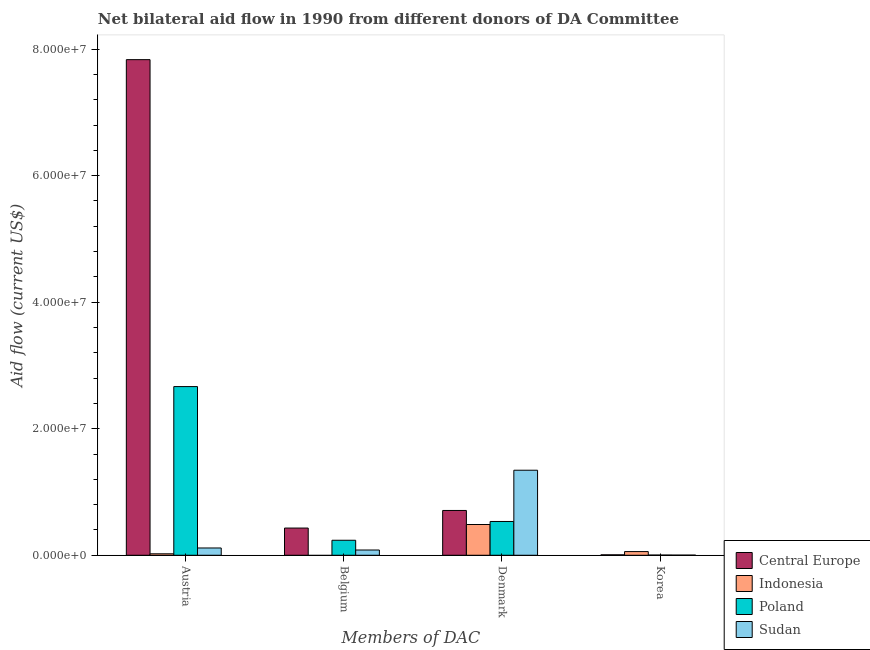How many different coloured bars are there?
Keep it short and to the point. 4. How many bars are there on the 3rd tick from the left?
Your answer should be compact. 4. What is the label of the 2nd group of bars from the left?
Your answer should be very brief. Belgium. What is the amount of aid given by austria in Central Europe?
Your answer should be compact. 7.83e+07. Across all countries, what is the maximum amount of aid given by belgium?
Offer a very short reply. 4.30e+06. Across all countries, what is the minimum amount of aid given by korea?
Your answer should be compact. 2.00e+04. In which country was the amount of aid given by belgium maximum?
Offer a very short reply. Central Europe. What is the total amount of aid given by denmark in the graph?
Keep it short and to the point. 3.07e+07. What is the difference between the amount of aid given by denmark in Poland and that in Sudan?
Your answer should be compact. -8.10e+06. What is the difference between the amount of aid given by belgium in Central Europe and the amount of aid given by austria in Poland?
Give a very brief answer. -2.24e+07. What is the average amount of aid given by belgium per country?
Provide a short and direct response. 1.88e+06. What is the difference between the amount of aid given by belgium and amount of aid given by austria in Sudan?
Provide a short and direct response. -3.20e+05. What is the ratio of the amount of aid given by austria in Indonesia to that in Central Europe?
Keep it short and to the point. 0. Is the amount of aid given by belgium in Sudan less than that in Central Europe?
Your answer should be very brief. Yes. Is the difference between the amount of aid given by korea in Central Europe and Indonesia greater than the difference between the amount of aid given by denmark in Central Europe and Indonesia?
Your response must be concise. No. What is the difference between the highest and the second highest amount of aid given by denmark?
Offer a very short reply. 6.36e+06. What is the difference between the highest and the lowest amount of aid given by belgium?
Provide a succinct answer. 4.30e+06. How many bars are there?
Your response must be concise. 15. How many countries are there in the graph?
Provide a short and direct response. 4. How are the legend labels stacked?
Provide a short and direct response. Vertical. What is the title of the graph?
Your answer should be compact. Net bilateral aid flow in 1990 from different donors of DA Committee. What is the label or title of the X-axis?
Offer a terse response. Members of DAC. What is the Aid flow (current US$) of Central Europe in Austria?
Make the answer very short. 7.83e+07. What is the Aid flow (current US$) in Poland in Austria?
Your answer should be compact. 2.67e+07. What is the Aid flow (current US$) in Sudan in Austria?
Your answer should be compact. 1.15e+06. What is the Aid flow (current US$) in Central Europe in Belgium?
Offer a terse response. 4.30e+06. What is the Aid flow (current US$) of Indonesia in Belgium?
Give a very brief answer. 0. What is the Aid flow (current US$) in Poland in Belgium?
Make the answer very short. 2.37e+06. What is the Aid flow (current US$) in Sudan in Belgium?
Your answer should be very brief. 8.30e+05. What is the Aid flow (current US$) in Central Europe in Denmark?
Provide a succinct answer. 7.08e+06. What is the Aid flow (current US$) of Indonesia in Denmark?
Offer a terse response. 4.86e+06. What is the Aid flow (current US$) in Poland in Denmark?
Offer a terse response. 5.34e+06. What is the Aid flow (current US$) in Sudan in Denmark?
Provide a short and direct response. 1.34e+07. What is the Aid flow (current US$) in Indonesia in Korea?
Offer a very short reply. 5.80e+05. Across all Members of DAC, what is the maximum Aid flow (current US$) in Central Europe?
Offer a very short reply. 7.83e+07. Across all Members of DAC, what is the maximum Aid flow (current US$) of Indonesia?
Your response must be concise. 4.86e+06. Across all Members of DAC, what is the maximum Aid flow (current US$) in Poland?
Your answer should be very brief. 2.67e+07. Across all Members of DAC, what is the maximum Aid flow (current US$) in Sudan?
Your answer should be compact. 1.34e+07. Across all Members of DAC, what is the minimum Aid flow (current US$) in Central Europe?
Ensure brevity in your answer.  7.00e+04. Across all Members of DAC, what is the minimum Aid flow (current US$) of Indonesia?
Your answer should be very brief. 0. Across all Members of DAC, what is the minimum Aid flow (current US$) in Poland?
Ensure brevity in your answer.  3.00e+04. Across all Members of DAC, what is the minimum Aid flow (current US$) in Sudan?
Give a very brief answer. 2.00e+04. What is the total Aid flow (current US$) in Central Europe in the graph?
Keep it short and to the point. 8.98e+07. What is the total Aid flow (current US$) in Indonesia in the graph?
Offer a very short reply. 5.67e+06. What is the total Aid flow (current US$) of Poland in the graph?
Provide a succinct answer. 3.44e+07. What is the total Aid flow (current US$) in Sudan in the graph?
Provide a short and direct response. 1.54e+07. What is the difference between the Aid flow (current US$) in Central Europe in Austria and that in Belgium?
Your answer should be very brief. 7.40e+07. What is the difference between the Aid flow (current US$) in Poland in Austria and that in Belgium?
Your answer should be very brief. 2.43e+07. What is the difference between the Aid flow (current US$) of Sudan in Austria and that in Belgium?
Make the answer very short. 3.20e+05. What is the difference between the Aid flow (current US$) of Central Europe in Austria and that in Denmark?
Make the answer very short. 7.12e+07. What is the difference between the Aid flow (current US$) of Indonesia in Austria and that in Denmark?
Your answer should be very brief. -4.63e+06. What is the difference between the Aid flow (current US$) in Poland in Austria and that in Denmark?
Keep it short and to the point. 2.13e+07. What is the difference between the Aid flow (current US$) in Sudan in Austria and that in Denmark?
Keep it short and to the point. -1.23e+07. What is the difference between the Aid flow (current US$) in Central Europe in Austria and that in Korea?
Your response must be concise. 7.83e+07. What is the difference between the Aid flow (current US$) in Indonesia in Austria and that in Korea?
Provide a succinct answer. -3.50e+05. What is the difference between the Aid flow (current US$) of Poland in Austria and that in Korea?
Your response must be concise. 2.66e+07. What is the difference between the Aid flow (current US$) of Sudan in Austria and that in Korea?
Keep it short and to the point. 1.13e+06. What is the difference between the Aid flow (current US$) of Central Europe in Belgium and that in Denmark?
Your answer should be compact. -2.78e+06. What is the difference between the Aid flow (current US$) in Poland in Belgium and that in Denmark?
Give a very brief answer. -2.97e+06. What is the difference between the Aid flow (current US$) in Sudan in Belgium and that in Denmark?
Your answer should be very brief. -1.26e+07. What is the difference between the Aid flow (current US$) of Central Europe in Belgium and that in Korea?
Provide a short and direct response. 4.23e+06. What is the difference between the Aid flow (current US$) of Poland in Belgium and that in Korea?
Provide a succinct answer. 2.34e+06. What is the difference between the Aid flow (current US$) of Sudan in Belgium and that in Korea?
Offer a terse response. 8.10e+05. What is the difference between the Aid flow (current US$) of Central Europe in Denmark and that in Korea?
Ensure brevity in your answer.  7.01e+06. What is the difference between the Aid flow (current US$) in Indonesia in Denmark and that in Korea?
Give a very brief answer. 4.28e+06. What is the difference between the Aid flow (current US$) of Poland in Denmark and that in Korea?
Ensure brevity in your answer.  5.31e+06. What is the difference between the Aid flow (current US$) in Sudan in Denmark and that in Korea?
Keep it short and to the point. 1.34e+07. What is the difference between the Aid flow (current US$) of Central Europe in Austria and the Aid flow (current US$) of Poland in Belgium?
Make the answer very short. 7.60e+07. What is the difference between the Aid flow (current US$) of Central Europe in Austria and the Aid flow (current US$) of Sudan in Belgium?
Your response must be concise. 7.75e+07. What is the difference between the Aid flow (current US$) in Indonesia in Austria and the Aid flow (current US$) in Poland in Belgium?
Provide a succinct answer. -2.14e+06. What is the difference between the Aid flow (current US$) of Indonesia in Austria and the Aid flow (current US$) of Sudan in Belgium?
Offer a terse response. -6.00e+05. What is the difference between the Aid flow (current US$) of Poland in Austria and the Aid flow (current US$) of Sudan in Belgium?
Provide a succinct answer. 2.58e+07. What is the difference between the Aid flow (current US$) in Central Europe in Austria and the Aid flow (current US$) in Indonesia in Denmark?
Your response must be concise. 7.35e+07. What is the difference between the Aid flow (current US$) of Central Europe in Austria and the Aid flow (current US$) of Poland in Denmark?
Make the answer very short. 7.30e+07. What is the difference between the Aid flow (current US$) in Central Europe in Austria and the Aid flow (current US$) in Sudan in Denmark?
Your response must be concise. 6.49e+07. What is the difference between the Aid flow (current US$) in Indonesia in Austria and the Aid flow (current US$) in Poland in Denmark?
Provide a short and direct response. -5.11e+06. What is the difference between the Aid flow (current US$) of Indonesia in Austria and the Aid flow (current US$) of Sudan in Denmark?
Make the answer very short. -1.32e+07. What is the difference between the Aid flow (current US$) in Poland in Austria and the Aid flow (current US$) in Sudan in Denmark?
Offer a terse response. 1.32e+07. What is the difference between the Aid flow (current US$) of Central Europe in Austria and the Aid flow (current US$) of Indonesia in Korea?
Your answer should be compact. 7.78e+07. What is the difference between the Aid flow (current US$) of Central Europe in Austria and the Aid flow (current US$) of Poland in Korea?
Offer a very short reply. 7.83e+07. What is the difference between the Aid flow (current US$) in Central Europe in Austria and the Aid flow (current US$) in Sudan in Korea?
Your answer should be compact. 7.83e+07. What is the difference between the Aid flow (current US$) of Poland in Austria and the Aid flow (current US$) of Sudan in Korea?
Offer a terse response. 2.66e+07. What is the difference between the Aid flow (current US$) of Central Europe in Belgium and the Aid flow (current US$) of Indonesia in Denmark?
Offer a very short reply. -5.60e+05. What is the difference between the Aid flow (current US$) in Central Europe in Belgium and the Aid flow (current US$) in Poland in Denmark?
Keep it short and to the point. -1.04e+06. What is the difference between the Aid flow (current US$) of Central Europe in Belgium and the Aid flow (current US$) of Sudan in Denmark?
Ensure brevity in your answer.  -9.14e+06. What is the difference between the Aid flow (current US$) of Poland in Belgium and the Aid flow (current US$) of Sudan in Denmark?
Give a very brief answer. -1.11e+07. What is the difference between the Aid flow (current US$) in Central Europe in Belgium and the Aid flow (current US$) in Indonesia in Korea?
Give a very brief answer. 3.72e+06. What is the difference between the Aid flow (current US$) in Central Europe in Belgium and the Aid flow (current US$) in Poland in Korea?
Offer a very short reply. 4.27e+06. What is the difference between the Aid flow (current US$) in Central Europe in Belgium and the Aid flow (current US$) in Sudan in Korea?
Make the answer very short. 4.28e+06. What is the difference between the Aid flow (current US$) of Poland in Belgium and the Aid flow (current US$) of Sudan in Korea?
Ensure brevity in your answer.  2.35e+06. What is the difference between the Aid flow (current US$) in Central Europe in Denmark and the Aid flow (current US$) in Indonesia in Korea?
Your answer should be compact. 6.50e+06. What is the difference between the Aid flow (current US$) of Central Europe in Denmark and the Aid flow (current US$) of Poland in Korea?
Keep it short and to the point. 7.05e+06. What is the difference between the Aid flow (current US$) of Central Europe in Denmark and the Aid flow (current US$) of Sudan in Korea?
Ensure brevity in your answer.  7.06e+06. What is the difference between the Aid flow (current US$) of Indonesia in Denmark and the Aid flow (current US$) of Poland in Korea?
Your response must be concise. 4.83e+06. What is the difference between the Aid flow (current US$) of Indonesia in Denmark and the Aid flow (current US$) of Sudan in Korea?
Provide a succinct answer. 4.84e+06. What is the difference between the Aid flow (current US$) in Poland in Denmark and the Aid flow (current US$) in Sudan in Korea?
Give a very brief answer. 5.32e+06. What is the average Aid flow (current US$) in Central Europe per Members of DAC?
Your response must be concise. 2.24e+07. What is the average Aid flow (current US$) of Indonesia per Members of DAC?
Offer a terse response. 1.42e+06. What is the average Aid flow (current US$) in Poland per Members of DAC?
Your answer should be compact. 8.60e+06. What is the average Aid flow (current US$) of Sudan per Members of DAC?
Offer a very short reply. 3.86e+06. What is the difference between the Aid flow (current US$) in Central Europe and Aid flow (current US$) in Indonesia in Austria?
Provide a succinct answer. 7.81e+07. What is the difference between the Aid flow (current US$) of Central Europe and Aid flow (current US$) of Poland in Austria?
Offer a terse response. 5.17e+07. What is the difference between the Aid flow (current US$) in Central Europe and Aid flow (current US$) in Sudan in Austria?
Give a very brief answer. 7.72e+07. What is the difference between the Aid flow (current US$) in Indonesia and Aid flow (current US$) in Poland in Austria?
Give a very brief answer. -2.64e+07. What is the difference between the Aid flow (current US$) in Indonesia and Aid flow (current US$) in Sudan in Austria?
Provide a succinct answer. -9.20e+05. What is the difference between the Aid flow (current US$) in Poland and Aid flow (current US$) in Sudan in Austria?
Provide a succinct answer. 2.55e+07. What is the difference between the Aid flow (current US$) of Central Europe and Aid flow (current US$) of Poland in Belgium?
Your answer should be compact. 1.93e+06. What is the difference between the Aid flow (current US$) of Central Europe and Aid flow (current US$) of Sudan in Belgium?
Offer a very short reply. 3.47e+06. What is the difference between the Aid flow (current US$) in Poland and Aid flow (current US$) in Sudan in Belgium?
Your answer should be compact. 1.54e+06. What is the difference between the Aid flow (current US$) in Central Europe and Aid flow (current US$) in Indonesia in Denmark?
Keep it short and to the point. 2.22e+06. What is the difference between the Aid flow (current US$) of Central Europe and Aid flow (current US$) of Poland in Denmark?
Your response must be concise. 1.74e+06. What is the difference between the Aid flow (current US$) of Central Europe and Aid flow (current US$) of Sudan in Denmark?
Your response must be concise. -6.36e+06. What is the difference between the Aid flow (current US$) in Indonesia and Aid flow (current US$) in Poland in Denmark?
Your response must be concise. -4.80e+05. What is the difference between the Aid flow (current US$) of Indonesia and Aid flow (current US$) of Sudan in Denmark?
Ensure brevity in your answer.  -8.58e+06. What is the difference between the Aid flow (current US$) of Poland and Aid flow (current US$) of Sudan in Denmark?
Offer a terse response. -8.10e+06. What is the difference between the Aid flow (current US$) of Central Europe and Aid flow (current US$) of Indonesia in Korea?
Ensure brevity in your answer.  -5.10e+05. What is the difference between the Aid flow (current US$) in Central Europe and Aid flow (current US$) in Poland in Korea?
Your answer should be very brief. 4.00e+04. What is the difference between the Aid flow (current US$) in Central Europe and Aid flow (current US$) in Sudan in Korea?
Provide a succinct answer. 5.00e+04. What is the difference between the Aid flow (current US$) in Indonesia and Aid flow (current US$) in Poland in Korea?
Your answer should be very brief. 5.50e+05. What is the difference between the Aid flow (current US$) of Indonesia and Aid flow (current US$) of Sudan in Korea?
Make the answer very short. 5.60e+05. What is the difference between the Aid flow (current US$) in Poland and Aid flow (current US$) in Sudan in Korea?
Offer a terse response. 10000. What is the ratio of the Aid flow (current US$) in Central Europe in Austria to that in Belgium?
Provide a succinct answer. 18.22. What is the ratio of the Aid flow (current US$) in Poland in Austria to that in Belgium?
Offer a terse response. 11.25. What is the ratio of the Aid flow (current US$) of Sudan in Austria to that in Belgium?
Ensure brevity in your answer.  1.39. What is the ratio of the Aid flow (current US$) in Central Europe in Austria to that in Denmark?
Ensure brevity in your answer.  11.06. What is the ratio of the Aid flow (current US$) of Indonesia in Austria to that in Denmark?
Provide a short and direct response. 0.05. What is the ratio of the Aid flow (current US$) in Poland in Austria to that in Denmark?
Offer a very short reply. 4.99. What is the ratio of the Aid flow (current US$) in Sudan in Austria to that in Denmark?
Make the answer very short. 0.09. What is the ratio of the Aid flow (current US$) of Central Europe in Austria to that in Korea?
Offer a terse response. 1119. What is the ratio of the Aid flow (current US$) of Indonesia in Austria to that in Korea?
Make the answer very short. 0.4. What is the ratio of the Aid flow (current US$) in Poland in Austria to that in Korea?
Offer a terse response. 888.67. What is the ratio of the Aid flow (current US$) of Sudan in Austria to that in Korea?
Your response must be concise. 57.5. What is the ratio of the Aid flow (current US$) in Central Europe in Belgium to that in Denmark?
Your answer should be very brief. 0.61. What is the ratio of the Aid flow (current US$) in Poland in Belgium to that in Denmark?
Your answer should be compact. 0.44. What is the ratio of the Aid flow (current US$) of Sudan in Belgium to that in Denmark?
Ensure brevity in your answer.  0.06. What is the ratio of the Aid flow (current US$) in Central Europe in Belgium to that in Korea?
Provide a succinct answer. 61.43. What is the ratio of the Aid flow (current US$) of Poland in Belgium to that in Korea?
Offer a terse response. 79. What is the ratio of the Aid flow (current US$) in Sudan in Belgium to that in Korea?
Offer a very short reply. 41.5. What is the ratio of the Aid flow (current US$) in Central Europe in Denmark to that in Korea?
Give a very brief answer. 101.14. What is the ratio of the Aid flow (current US$) of Indonesia in Denmark to that in Korea?
Your answer should be compact. 8.38. What is the ratio of the Aid flow (current US$) of Poland in Denmark to that in Korea?
Give a very brief answer. 178. What is the ratio of the Aid flow (current US$) of Sudan in Denmark to that in Korea?
Keep it short and to the point. 672. What is the difference between the highest and the second highest Aid flow (current US$) of Central Europe?
Provide a short and direct response. 7.12e+07. What is the difference between the highest and the second highest Aid flow (current US$) in Indonesia?
Your response must be concise. 4.28e+06. What is the difference between the highest and the second highest Aid flow (current US$) in Poland?
Provide a succinct answer. 2.13e+07. What is the difference between the highest and the second highest Aid flow (current US$) in Sudan?
Your response must be concise. 1.23e+07. What is the difference between the highest and the lowest Aid flow (current US$) in Central Europe?
Offer a very short reply. 7.83e+07. What is the difference between the highest and the lowest Aid flow (current US$) of Indonesia?
Keep it short and to the point. 4.86e+06. What is the difference between the highest and the lowest Aid flow (current US$) of Poland?
Offer a very short reply. 2.66e+07. What is the difference between the highest and the lowest Aid flow (current US$) of Sudan?
Offer a terse response. 1.34e+07. 